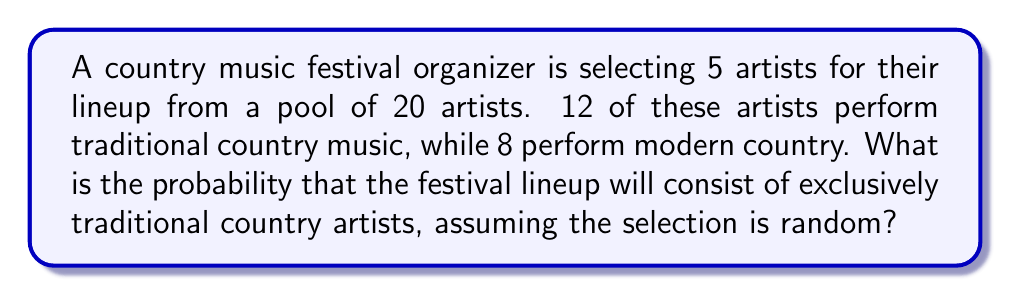Can you solve this math problem? Let's approach this step-by-step:

1) This is a combination problem. We need to select 5 artists out of 12 traditional country artists.

2) The number of ways to select 5 traditional artists out of 12 is given by the combination formula:

   $$\binom{12}{5} = \frac{12!}{5!(12-5)!} = \frac{12!}{5!7!}$$

3) Let's calculate this:
   $$\frac{12 * 11 * 10 * 9 * 8 * 7!}{(5 * 4 * 3 * 2 * 1) * 7!} = 792$$

4) Now, we need to consider the total number of ways to select 5 artists out of 20:

   $$\binom{20}{5} = \frac{20!}{5!(20-5)!} = \frac{20!}{5!15!}$$

5) Let's calculate this:
   $$\frac{20 * 19 * 18 * 17 * 16 * 15!}{(5 * 4 * 3 * 2 * 1) * 15!} = 15504$$

6) The probability is the number of favorable outcomes divided by the total number of possible outcomes:

   $$P(\text{all traditional}) = \frac{\binom{12}{5}}{\binom{20}{5}} = \frac{792}{15504} = \frac{99}{1938} \approx 0.0511$$
Answer: $\frac{99}{1938}$ or approximately 0.0511 or 5.11% 